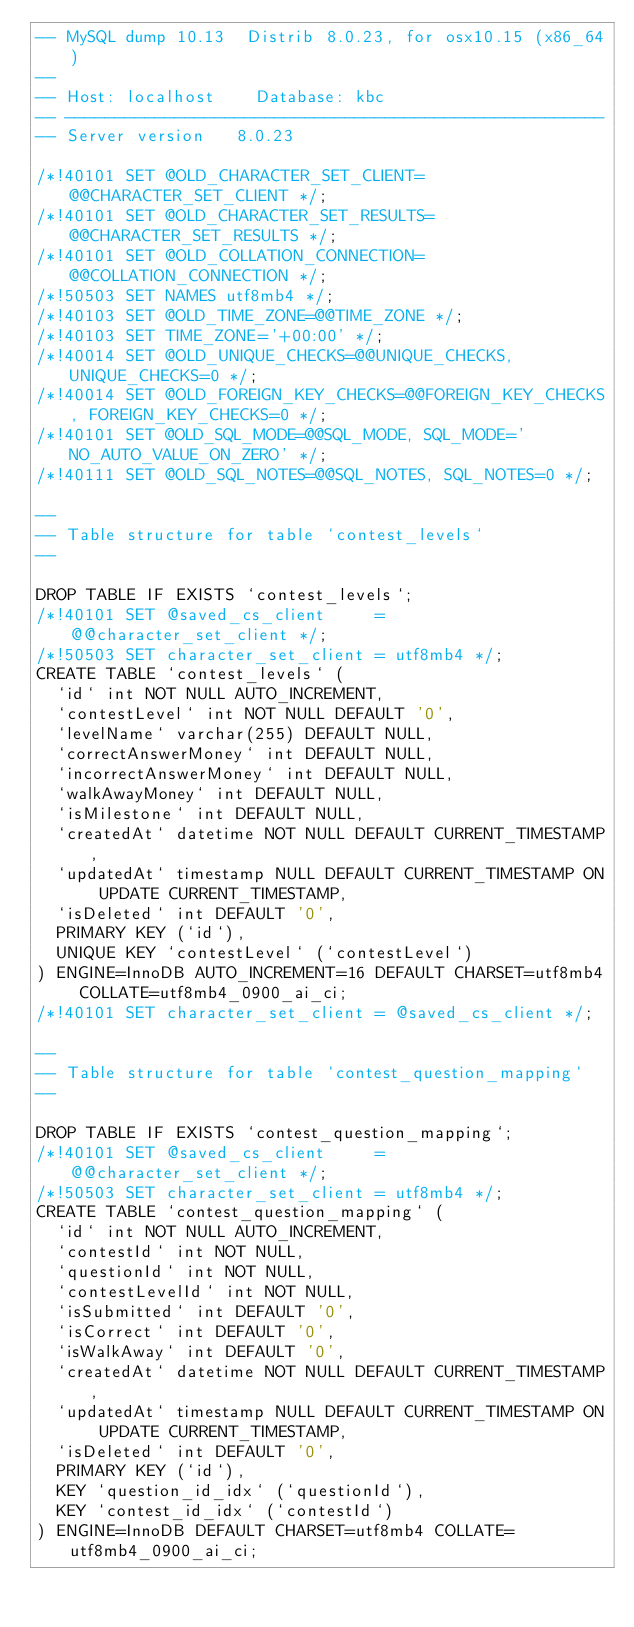<code> <loc_0><loc_0><loc_500><loc_500><_SQL_>-- MySQL dump 10.13  Distrib 8.0.23, for osx10.15 (x86_64)
--
-- Host: localhost    Database: kbc
-- ------------------------------------------------------
-- Server version	8.0.23

/*!40101 SET @OLD_CHARACTER_SET_CLIENT=@@CHARACTER_SET_CLIENT */;
/*!40101 SET @OLD_CHARACTER_SET_RESULTS=@@CHARACTER_SET_RESULTS */;
/*!40101 SET @OLD_COLLATION_CONNECTION=@@COLLATION_CONNECTION */;
/*!50503 SET NAMES utf8mb4 */;
/*!40103 SET @OLD_TIME_ZONE=@@TIME_ZONE */;
/*!40103 SET TIME_ZONE='+00:00' */;
/*!40014 SET @OLD_UNIQUE_CHECKS=@@UNIQUE_CHECKS, UNIQUE_CHECKS=0 */;
/*!40014 SET @OLD_FOREIGN_KEY_CHECKS=@@FOREIGN_KEY_CHECKS, FOREIGN_KEY_CHECKS=0 */;
/*!40101 SET @OLD_SQL_MODE=@@SQL_MODE, SQL_MODE='NO_AUTO_VALUE_ON_ZERO' */;
/*!40111 SET @OLD_SQL_NOTES=@@SQL_NOTES, SQL_NOTES=0 */;

--
-- Table structure for table `contest_levels`
--

DROP TABLE IF EXISTS `contest_levels`;
/*!40101 SET @saved_cs_client     = @@character_set_client */;
/*!50503 SET character_set_client = utf8mb4 */;
CREATE TABLE `contest_levels` (
  `id` int NOT NULL AUTO_INCREMENT,
  `contestLevel` int NOT NULL DEFAULT '0',
  `levelName` varchar(255) DEFAULT NULL,
  `correctAnswerMoney` int DEFAULT NULL,
  `incorrectAnswerMoney` int DEFAULT NULL,
  `walkAwayMoney` int DEFAULT NULL,
  `isMilestone` int DEFAULT NULL,
  `createdAt` datetime NOT NULL DEFAULT CURRENT_TIMESTAMP,
  `updatedAt` timestamp NULL DEFAULT CURRENT_TIMESTAMP ON UPDATE CURRENT_TIMESTAMP,
  `isDeleted` int DEFAULT '0',
  PRIMARY KEY (`id`),
  UNIQUE KEY `contestLevel` (`contestLevel`)
) ENGINE=InnoDB AUTO_INCREMENT=16 DEFAULT CHARSET=utf8mb4 COLLATE=utf8mb4_0900_ai_ci;
/*!40101 SET character_set_client = @saved_cs_client */;

--
-- Table structure for table `contest_question_mapping`
--

DROP TABLE IF EXISTS `contest_question_mapping`;
/*!40101 SET @saved_cs_client     = @@character_set_client */;
/*!50503 SET character_set_client = utf8mb4 */;
CREATE TABLE `contest_question_mapping` (
  `id` int NOT NULL AUTO_INCREMENT,
  `contestId` int NOT NULL,
  `questionId` int NOT NULL,
  `contestLevelId` int NOT NULL,
  `isSubmitted` int DEFAULT '0',
  `isCorrect` int DEFAULT '0',
  `isWalkAway` int DEFAULT '0',
  `createdAt` datetime NOT NULL DEFAULT CURRENT_TIMESTAMP,
  `updatedAt` timestamp NULL DEFAULT CURRENT_TIMESTAMP ON UPDATE CURRENT_TIMESTAMP,
  `isDeleted` int DEFAULT '0',
  PRIMARY KEY (`id`),
  KEY `question_id_idx` (`questionId`),
  KEY `contest_id_idx` (`contestId`)
) ENGINE=InnoDB DEFAULT CHARSET=utf8mb4 COLLATE=utf8mb4_0900_ai_ci;</code> 